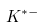Convert formula to latex. <formula><loc_0><loc_0><loc_500><loc_500>K ^ { * - }</formula> 